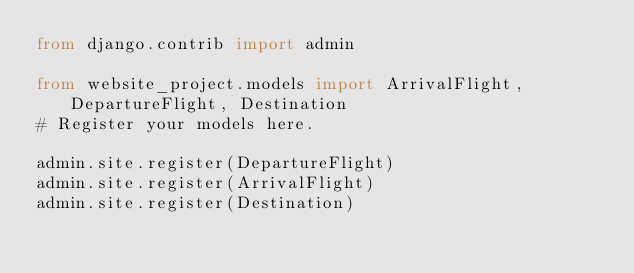<code> <loc_0><loc_0><loc_500><loc_500><_Python_>from django.contrib import admin

from website_project.models import ArrivalFlight, DepartureFlight, Destination
# Register your models here.

admin.site.register(DepartureFlight)
admin.site.register(ArrivalFlight)
admin.site.register(Destination)
</code> 